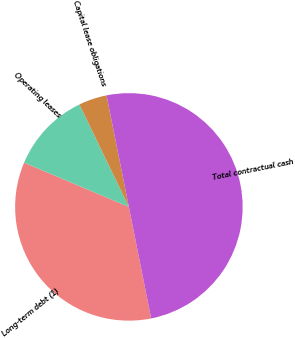Convert chart. <chart><loc_0><loc_0><loc_500><loc_500><pie_chart><fcel>Long-term debt (1)<fcel>Operating leases<fcel>Capital lease obligations<fcel>Total contractual cash<nl><fcel>34.5%<fcel>11.48%<fcel>4.01%<fcel>50.0%<nl></chart> 